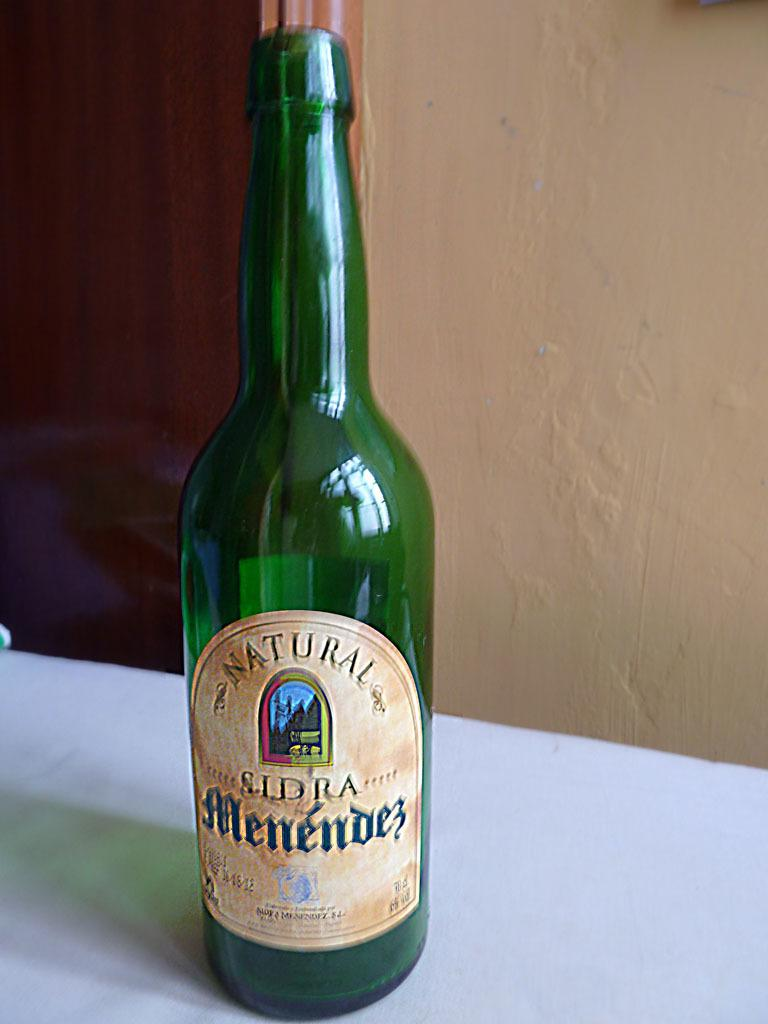<image>
Create a compact narrative representing the image presented. A green bottle of Natural Menendez sits alone on a table. 